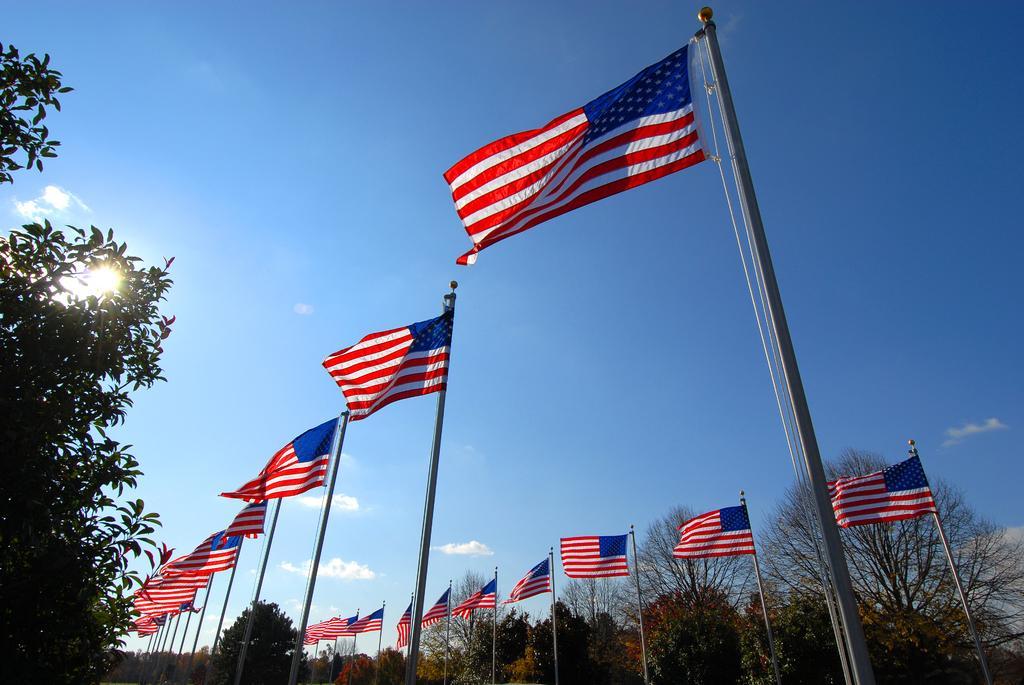In one or two sentences, can you explain what this image depicts? As we can see in the image there are trees, flags, sun, sky and clouds. 